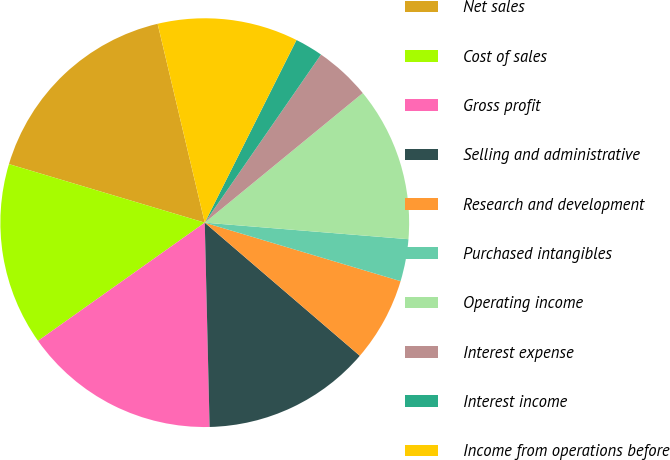Convert chart. <chart><loc_0><loc_0><loc_500><loc_500><pie_chart><fcel>Net sales<fcel>Cost of sales<fcel>Gross profit<fcel>Selling and administrative<fcel>Research and development<fcel>Purchased intangibles<fcel>Operating income<fcel>Interest expense<fcel>Interest income<fcel>Income from operations before<nl><fcel>16.67%<fcel>14.44%<fcel>15.56%<fcel>13.33%<fcel>6.67%<fcel>3.33%<fcel>12.22%<fcel>4.44%<fcel>2.22%<fcel>11.11%<nl></chart> 